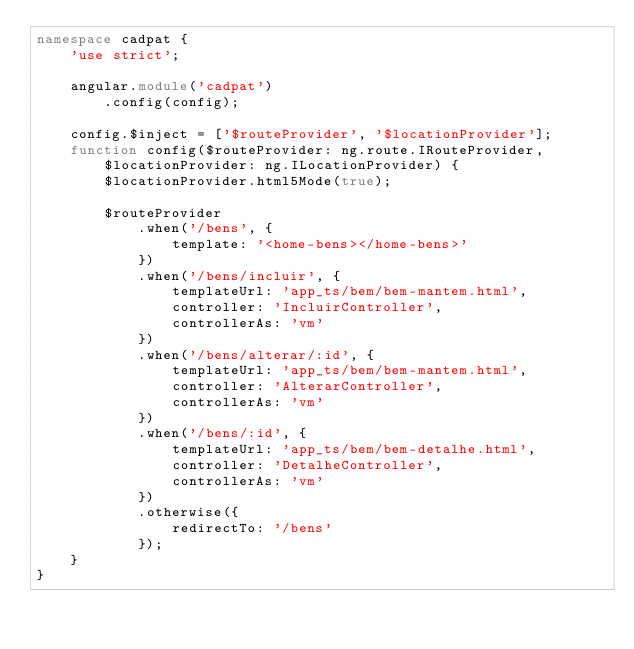Convert code to text. <code><loc_0><loc_0><loc_500><loc_500><_TypeScript_>namespace cadpat {
    'use strict';

    angular.module('cadpat')
        .config(config);

    config.$inject = ['$routeProvider', '$locationProvider'];
    function config($routeProvider: ng.route.IRouteProvider,
        $locationProvider: ng.ILocationProvider) {
        $locationProvider.html5Mode(true);

        $routeProvider
            .when('/bens', {
                template: '<home-bens></home-bens>'
            })
            .when('/bens/incluir', {
                templateUrl: 'app_ts/bem/bem-mantem.html',
                controller: 'IncluirController',
                controllerAs: 'vm'
            })
            .when('/bens/alterar/:id', {
                templateUrl: 'app_ts/bem/bem-mantem.html',
                controller: 'AlterarController',
                controllerAs: 'vm'
            })
            .when('/bens/:id', {
                templateUrl: 'app_ts/bem/bem-detalhe.html',
                controller: 'DetalheController',
                controllerAs: 'vm'
            })
            .otherwise({
                redirectTo: '/bens'
            });
    }
}
</code> 